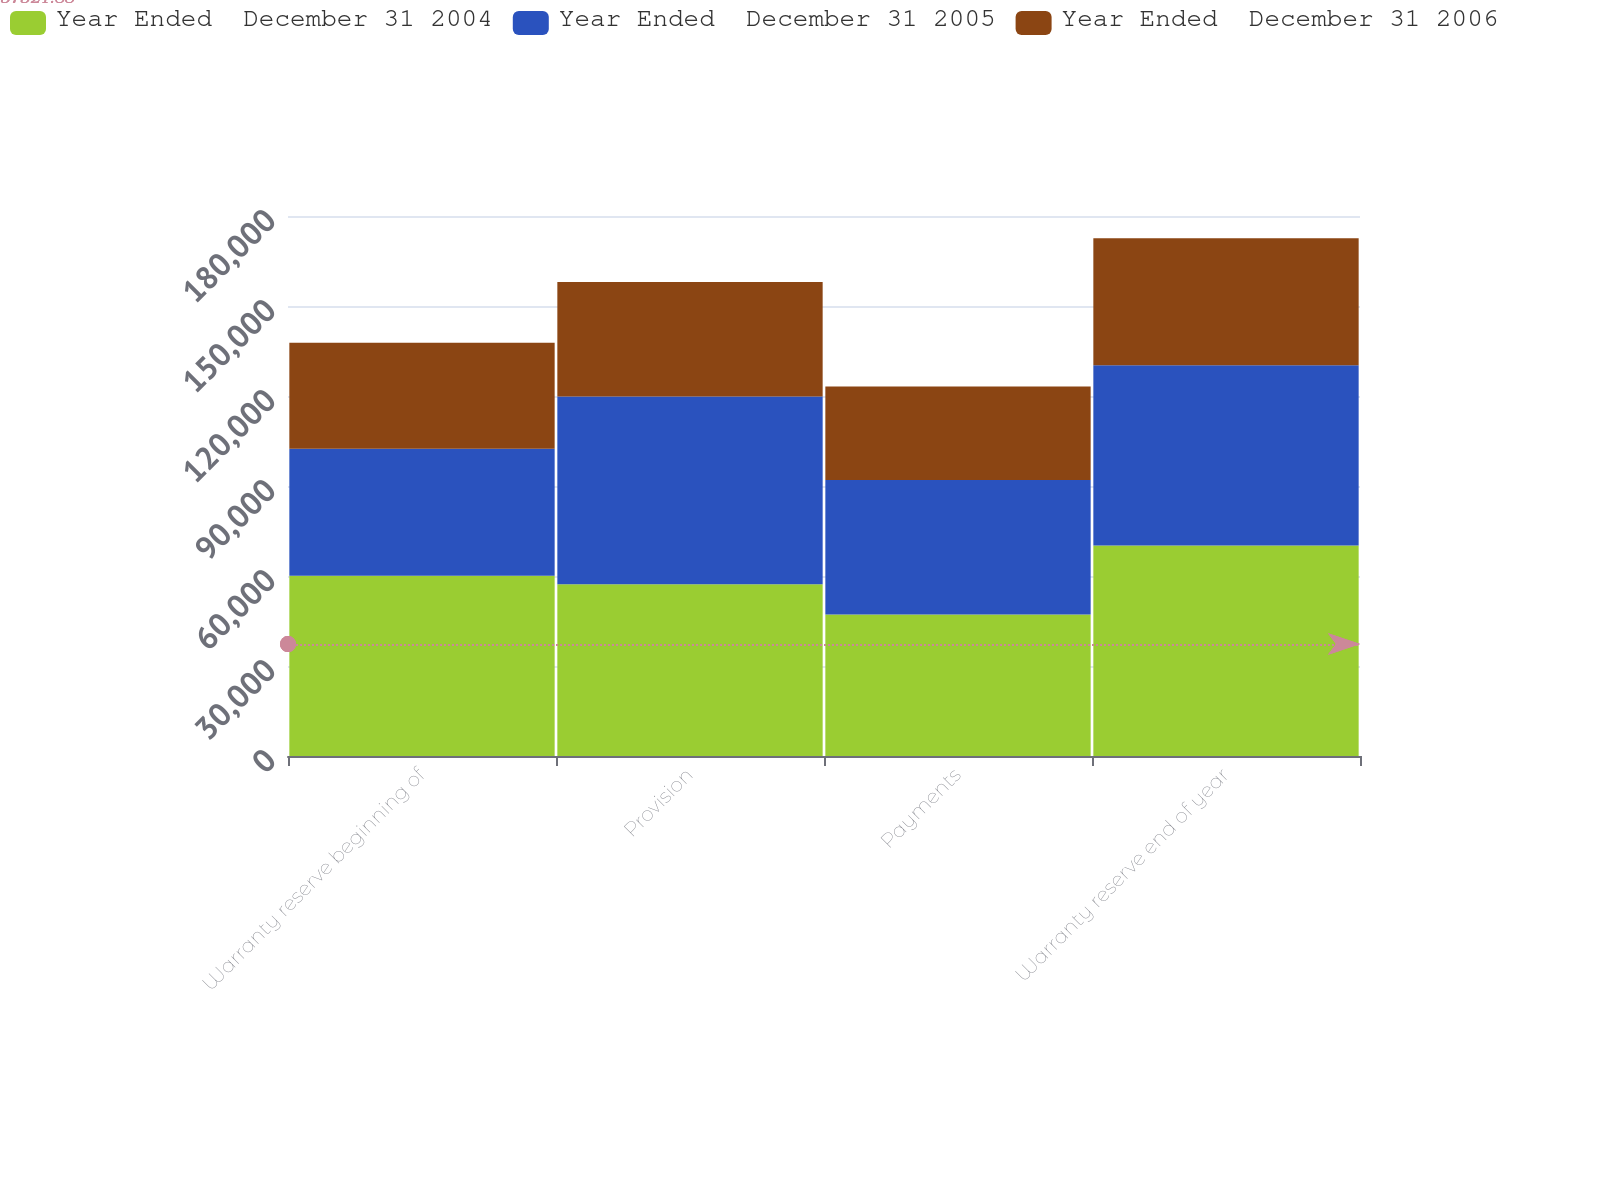<chart> <loc_0><loc_0><loc_500><loc_500><stacked_bar_chart><ecel><fcel>Warranty reserve beginning of<fcel>Provision<fcel>Payments<fcel>Warranty reserve end of year<nl><fcel>Year Ended  December 31 2004<fcel>60112<fcel>57222<fcel>47159<fcel>70175<nl><fcel>Year Ended  December 31 2005<fcel>42319<fcel>62598<fcel>44805<fcel>60112<nl><fcel>Year Ended  December 31 2006<fcel>35324<fcel>38178<fcel>31183<fcel>42319<nl></chart> 